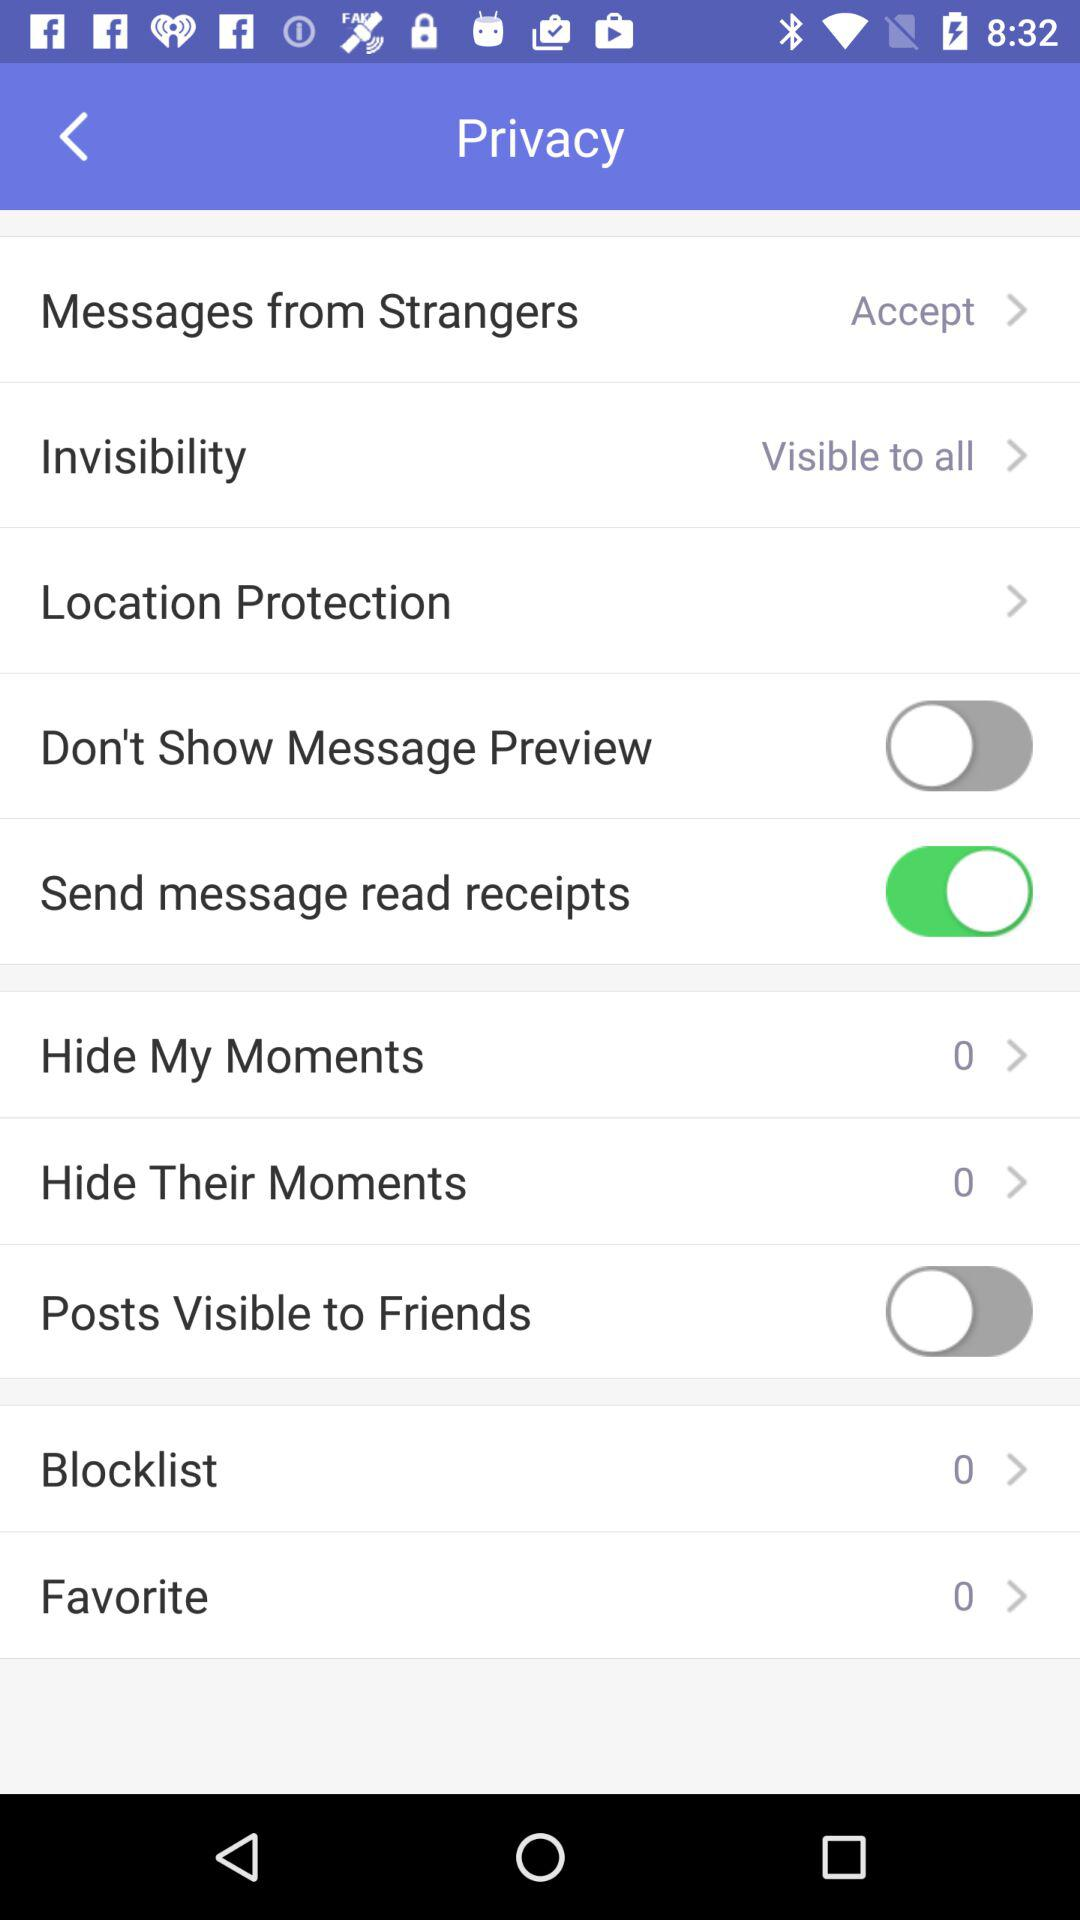What is the selected privacy setting for "Messages from Strangers"? The setting is "Accept". 